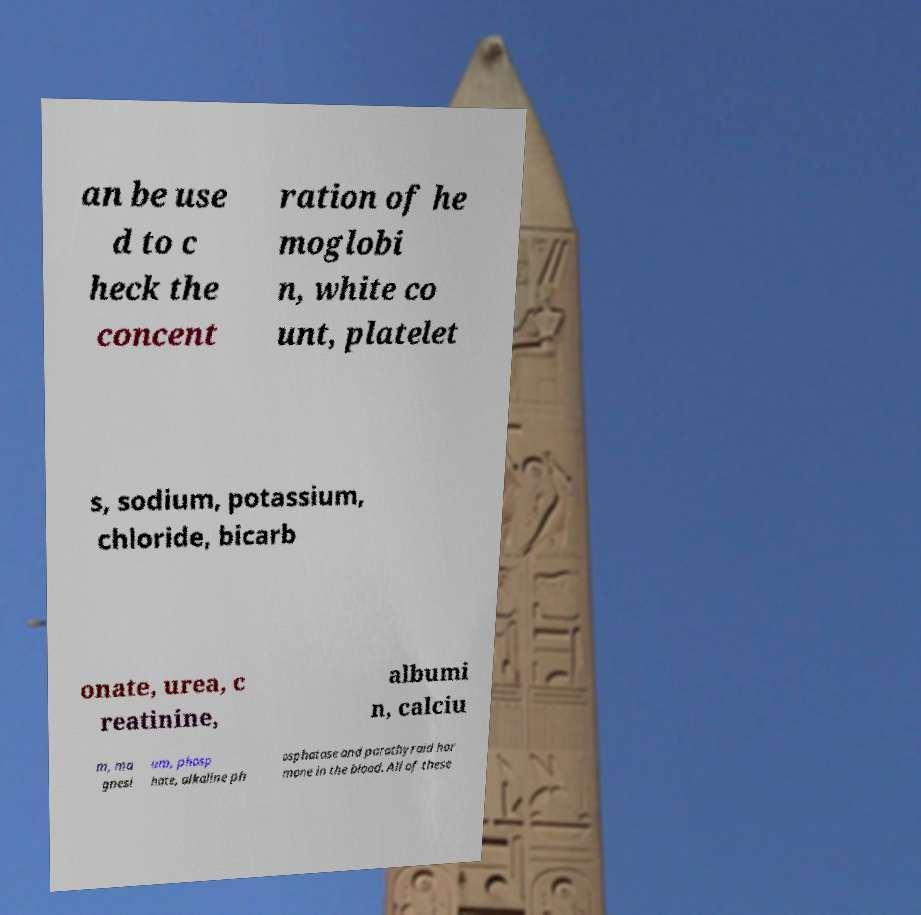Could you extract and type out the text from this image? an be use d to c heck the concent ration of he moglobi n, white co unt, platelet s, sodium, potassium, chloride, bicarb onate, urea, c reatinine, albumi n, calciu m, ma gnesi um, phosp hate, alkaline ph osphatase and parathyroid hor mone in the blood. All of these 